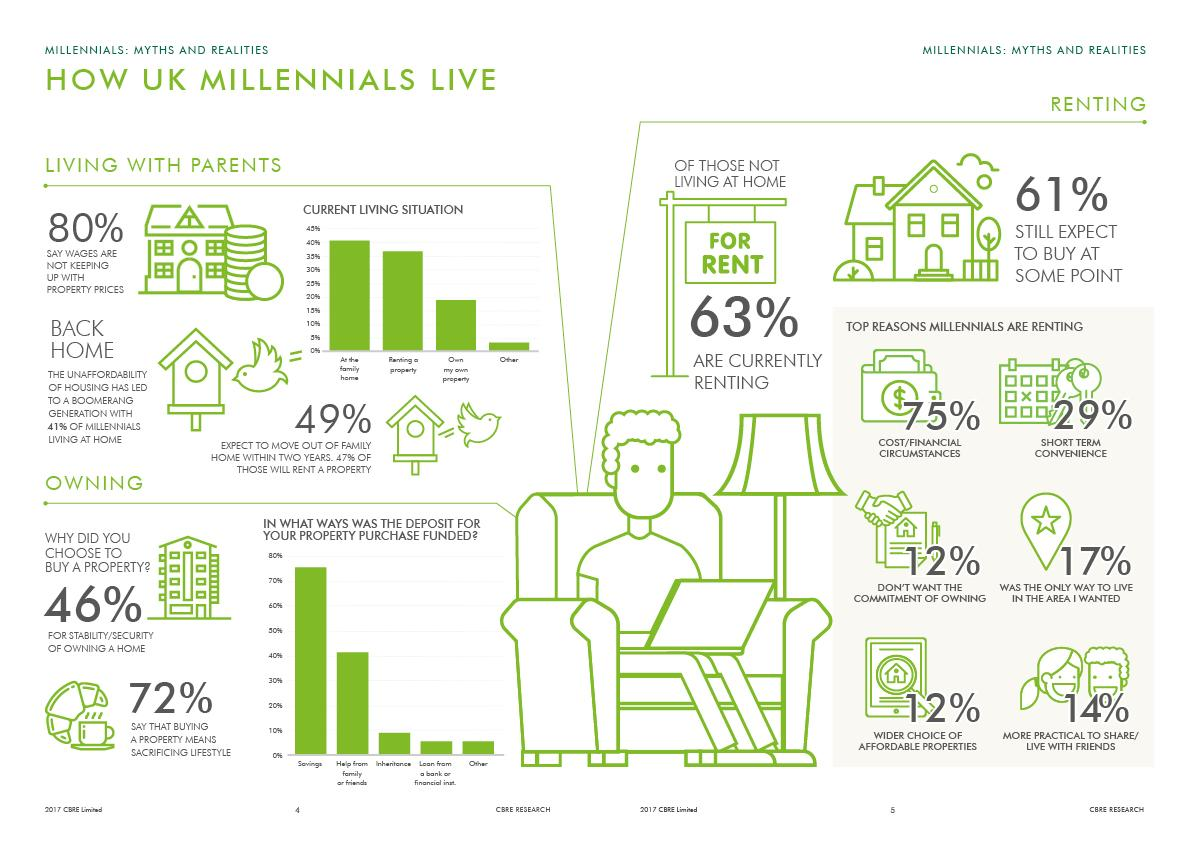Identify some key points in this picture. Millennials are more likely to rent due to the high cost and financial circumstances. Millennials are renting primarily due to short-term convenience, which is the second most common reason for their housing choice. Many millennials are choosing to live with their parents instead of renting a property on their own. This is the second most common living situation for millennials. The most common living situation for millennials who are still living with their parents is at the family home. Renting is the fourth most common reason that millennials choose to share or live with friends, making it a more practical and convenient lifestyle choice. 